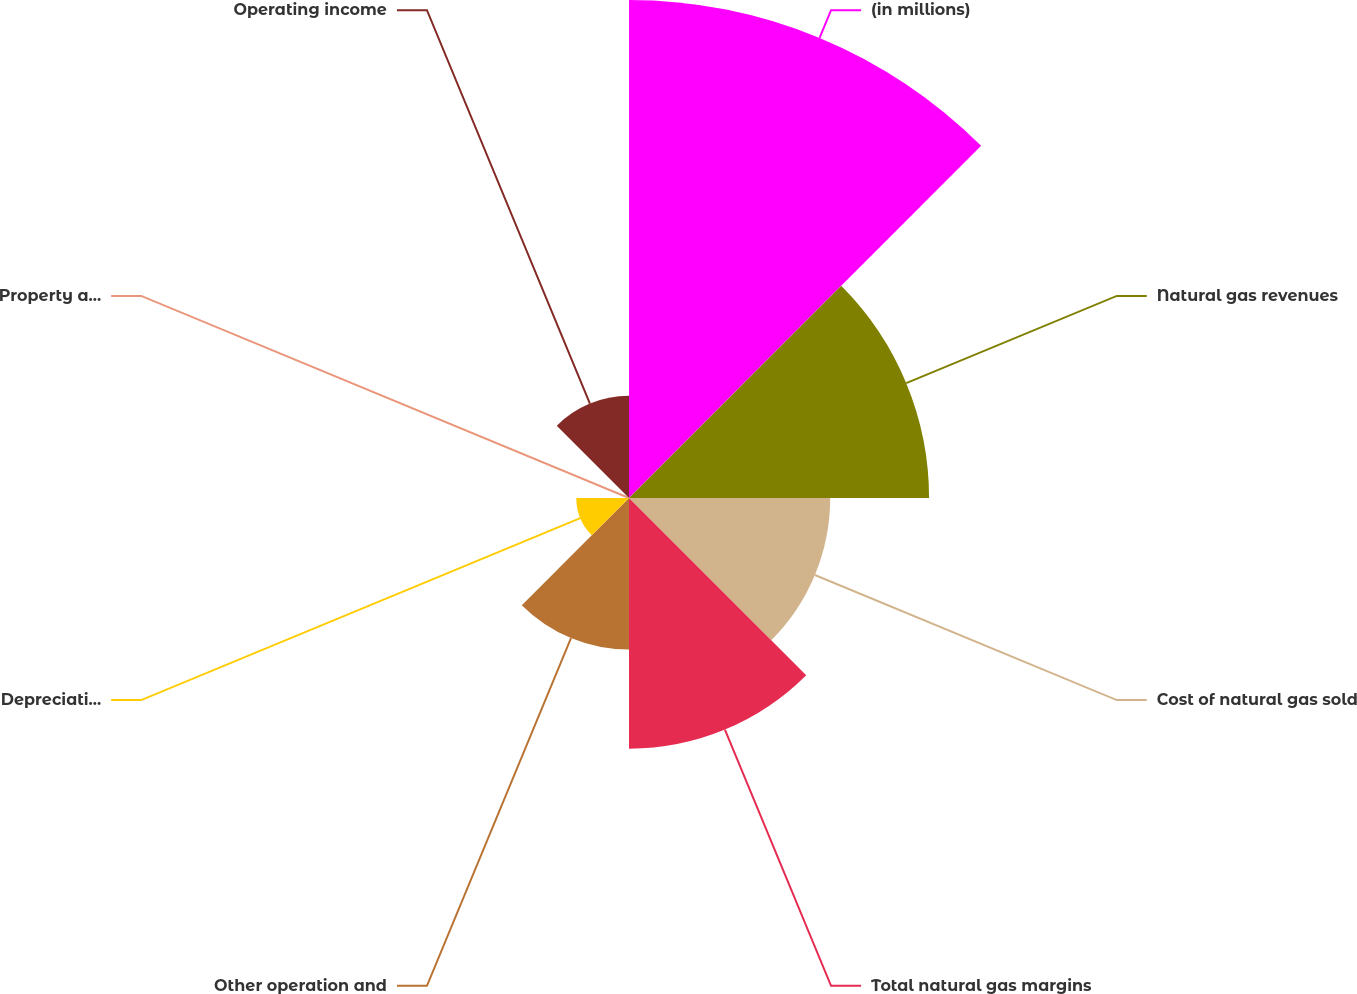<chart> <loc_0><loc_0><loc_500><loc_500><pie_chart><fcel>(in millions)<fcel>Natural gas revenues<fcel>Cost of natural gas sold<fcel>Total natural gas margins<fcel>Other operation and<fcel>Depreciation and amortization<fcel>Property and revenue taxes<fcel>Operating income<nl><fcel>31.93%<fcel>19.24%<fcel>12.9%<fcel>16.07%<fcel>9.72%<fcel>3.38%<fcel>0.21%<fcel>6.55%<nl></chart> 